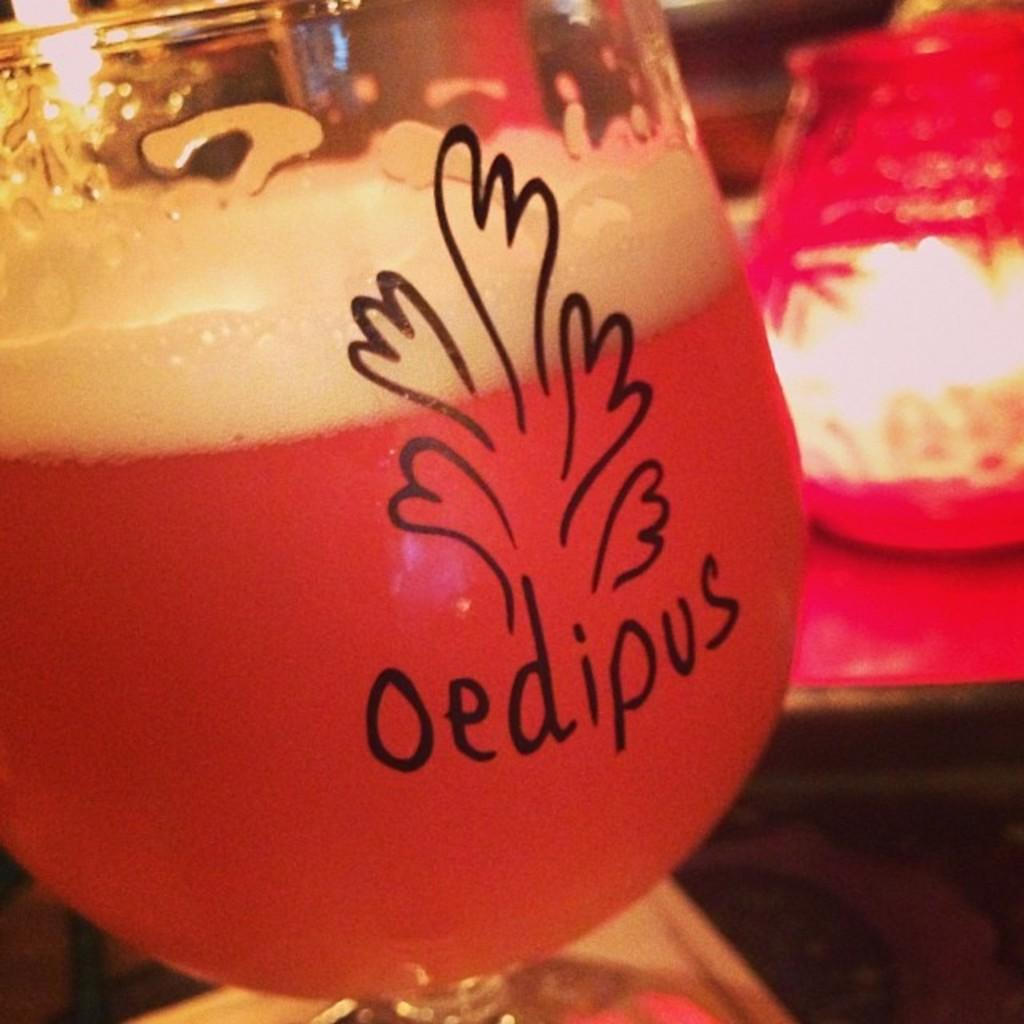What is the main object in the center of the image? There is a glass in the center of the image. Can you describe the background of the image? The background of the image is blurry. What is written or visible on the glass? There is text written on the glass. What type of toothpaste is being advertised on the glass in the image? There is no toothpaste or toothpaste present in the image. How does the horn in the image affect the acoustics of the room? There is no horn present in the image, so its effect on the acoustics cannot be determined. 